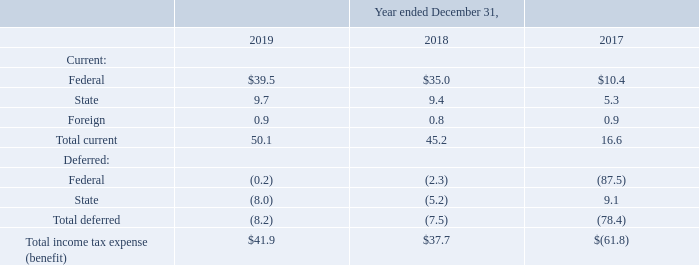(19) Income Taxes
Income tax expense (benefit) consists of the following (in millions):
On December 22, 2017, the Tax Reform Act was signed into law. Among other provisions, the Tax Reform Act reduced the federal statutory corporate income tax rate from 35% to 21%. During the fourth quarter of 2017, we recorded a one-time, noncash net tax benefit of $110.9 million related to the revaluation of our deferred income tax assets and liabilities as a result of the Tax Reform Act.
Which years does the table provide information for the company's income tax expense (benefit)? 2019, 2018, 2017. When was the the Tax Reform Act signed into law?  December 22, 2017. What was the current federal income tax expense in 2019?
Answer scale should be: million. 39.5. How many years did current state income tax benefit exceed $8 million? 2019##2018
Answer: 2. What was the change in the Total income tax expense between 2018 and 2019?
Answer scale should be: million. 41.9-37.7
Answer: 4.2. What was the percentage change in the total current income tax benefit between 2018 and 2019?
Answer scale should be: percent. (50.1-45.2)/45.2
Answer: 10.84. 